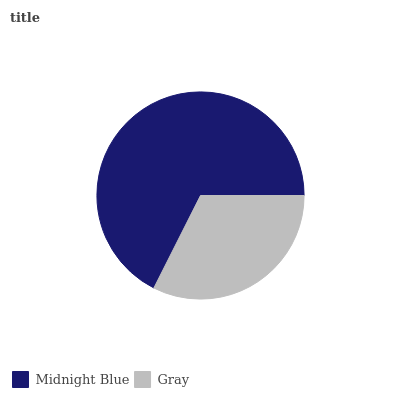Is Gray the minimum?
Answer yes or no. Yes. Is Midnight Blue the maximum?
Answer yes or no. Yes. Is Gray the maximum?
Answer yes or no. No. Is Midnight Blue greater than Gray?
Answer yes or no. Yes. Is Gray less than Midnight Blue?
Answer yes or no. Yes. Is Gray greater than Midnight Blue?
Answer yes or no. No. Is Midnight Blue less than Gray?
Answer yes or no. No. Is Midnight Blue the high median?
Answer yes or no. Yes. Is Gray the low median?
Answer yes or no. Yes. Is Gray the high median?
Answer yes or no. No. Is Midnight Blue the low median?
Answer yes or no. No. 